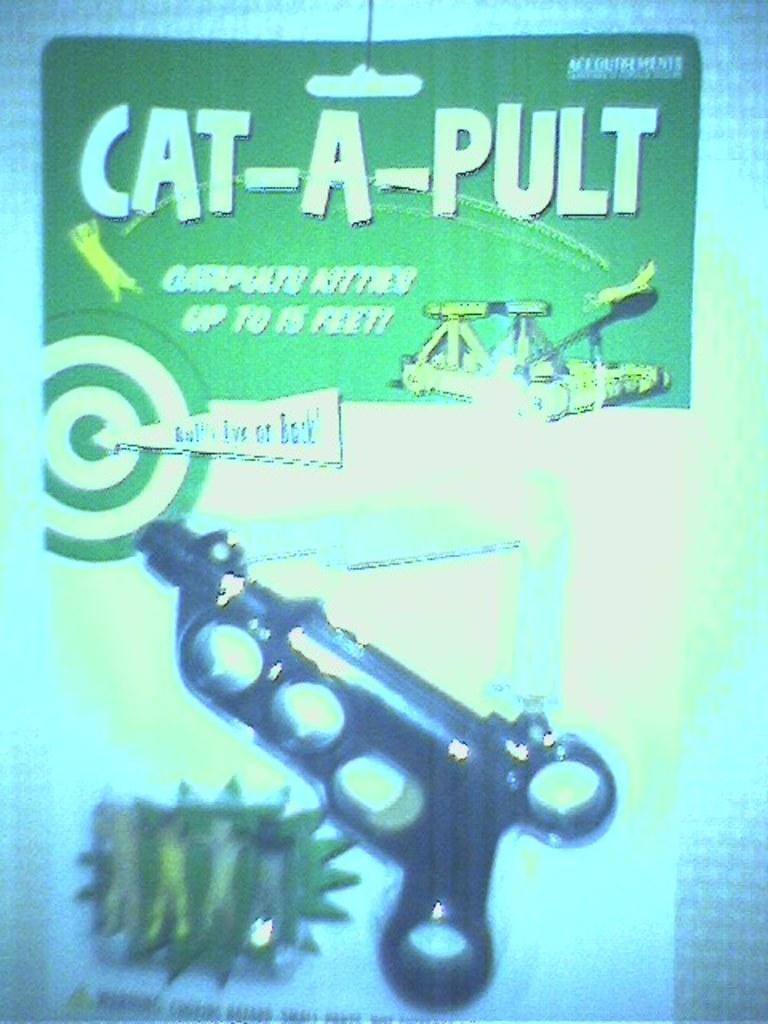<image>
Provide a brief description of the given image. A toy named a cat a pult inside its green packaging. 